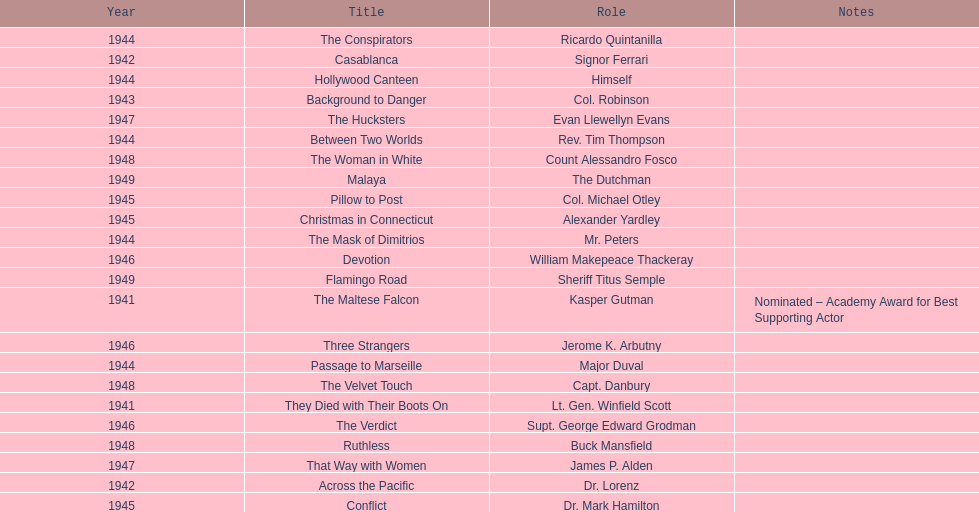What are all of the movies sydney greenstreet acted in? The Maltese Falcon, They Died with Their Boots On, Across the Pacific, Casablanca, Background to Danger, Passage to Marseille, Between Two Worlds, The Mask of Dimitrios, The Conspirators, Hollywood Canteen, Pillow to Post, Conflict, Christmas in Connecticut, Three Strangers, Devotion, The Verdict, That Way with Women, The Hucksters, The Velvet Touch, Ruthless, The Woman in White, Flamingo Road, Malaya. What are all of the title notes? Nominated – Academy Award for Best Supporting Actor. Which film was the award for? The Maltese Falcon. 